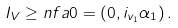Convert formula to latex. <formula><loc_0><loc_0><loc_500><loc_500>I _ { V } \geq n f a 0 = ( 0 , i _ { v _ { 1 } } \alpha _ { 1 } ) \, .</formula> 